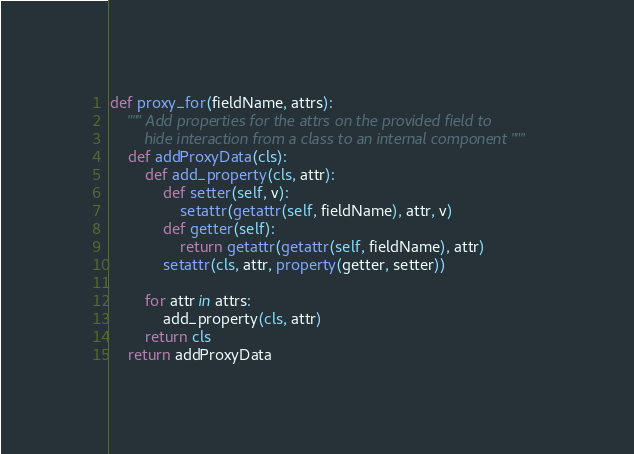<code> <loc_0><loc_0><loc_500><loc_500><_Python_>
def proxy_for(fieldName, attrs):
    """ Add properties for the attrs on the provided field to 
        hide interaction from a class to an internal component """
    def addProxyData(cls):
        def add_property(cls, attr):
            def setter(self, v):
                setattr(getattr(self, fieldName), attr, v)
            def getter(self):
                return getattr(getattr(self, fieldName), attr)
            setattr(cls, attr, property(getter, setter))
            
        for attr in attrs:
            add_property(cls, attr)
        return cls
    return addProxyData</code> 